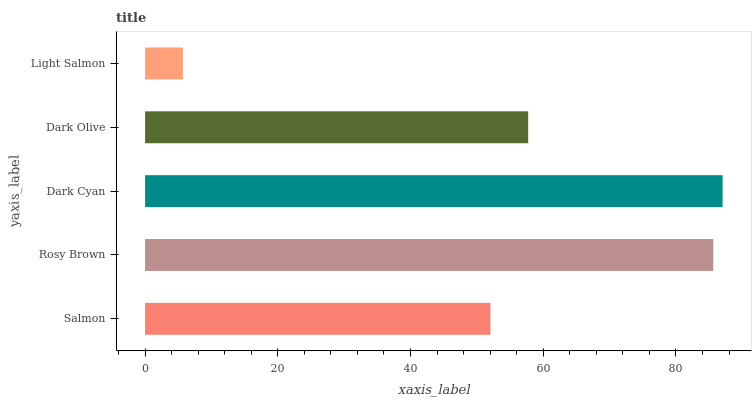Is Light Salmon the minimum?
Answer yes or no. Yes. Is Dark Cyan the maximum?
Answer yes or no. Yes. Is Rosy Brown the minimum?
Answer yes or no. No. Is Rosy Brown the maximum?
Answer yes or no. No. Is Rosy Brown greater than Salmon?
Answer yes or no. Yes. Is Salmon less than Rosy Brown?
Answer yes or no. Yes. Is Salmon greater than Rosy Brown?
Answer yes or no. No. Is Rosy Brown less than Salmon?
Answer yes or no. No. Is Dark Olive the high median?
Answer yes or no. Yes. Is Dark Olive the low median?
Answer yes or no. Yes. Is Salmon the high median?
Answer yes or no. No. Is Salmon the low median?
Answer yes or no. No. 